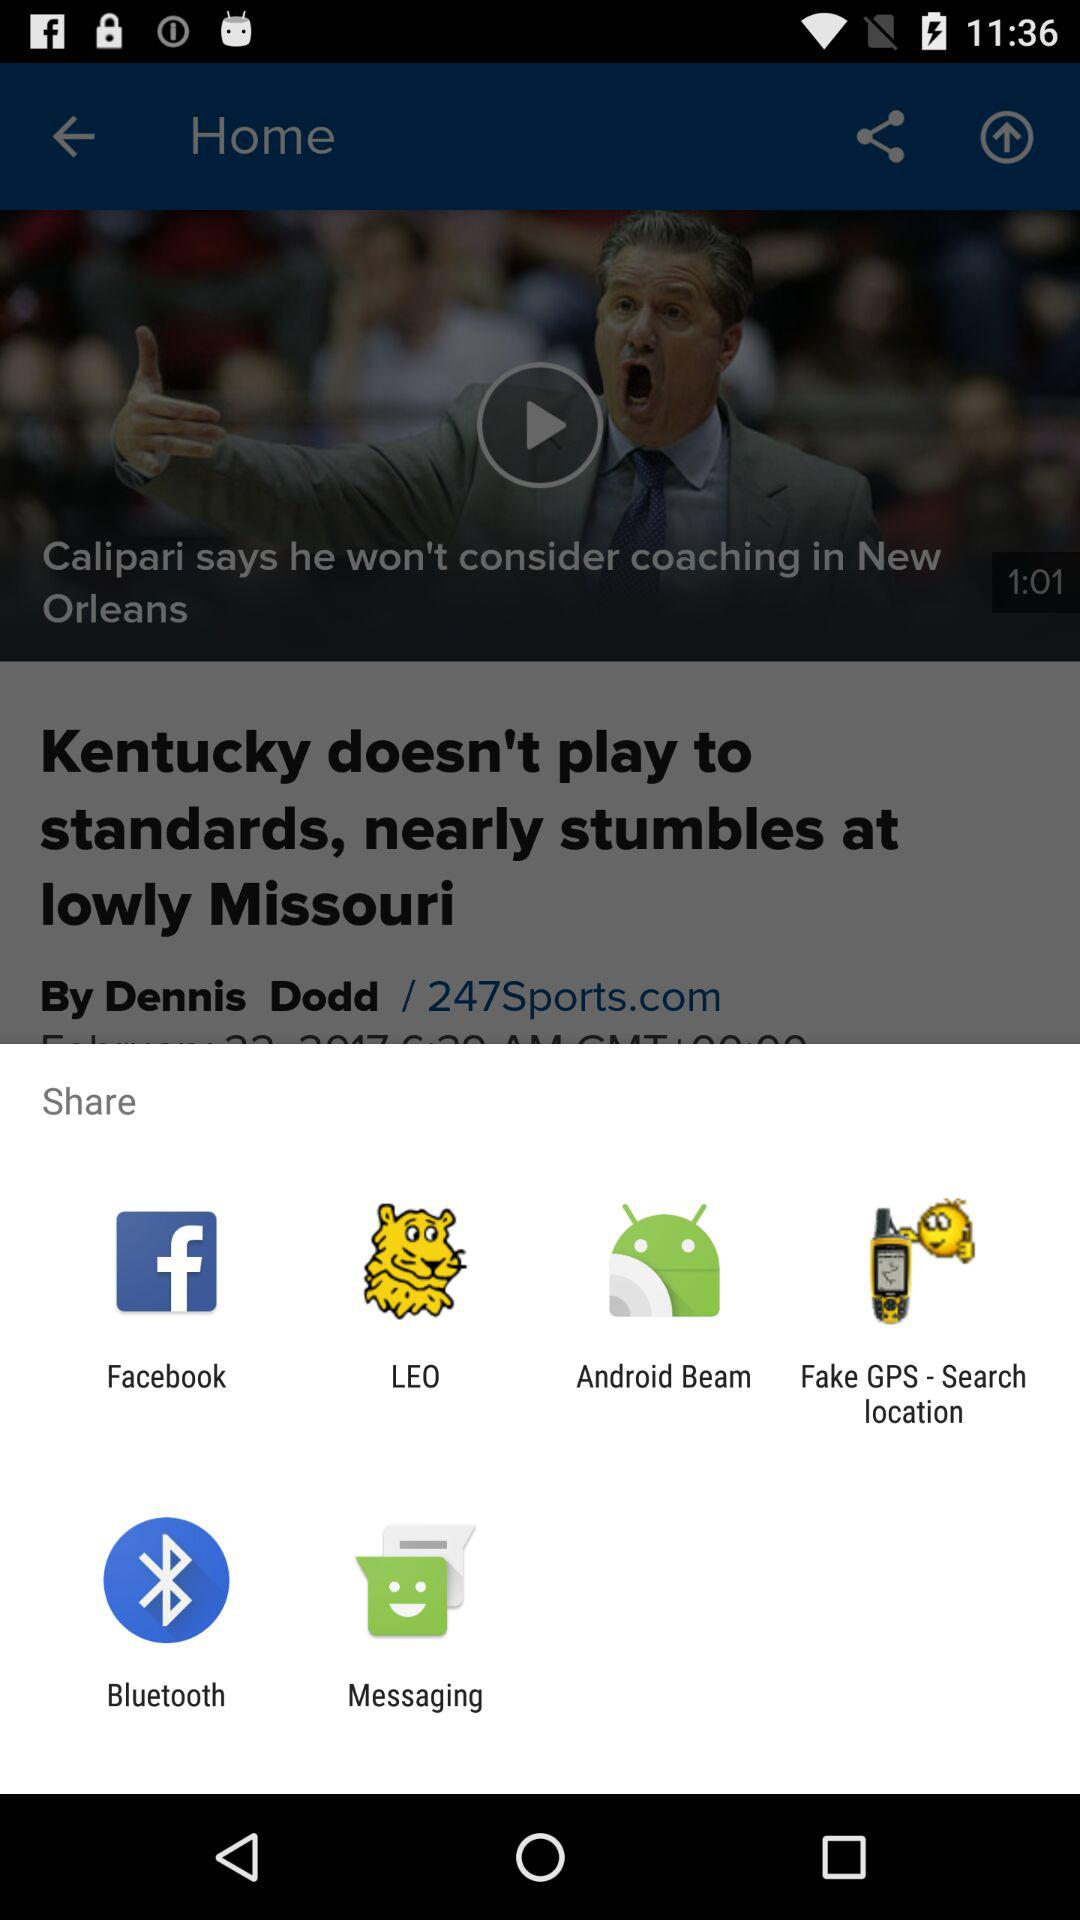When was the article published?
When the provided information is insufficient, respond with <no answer>. <no answer> 